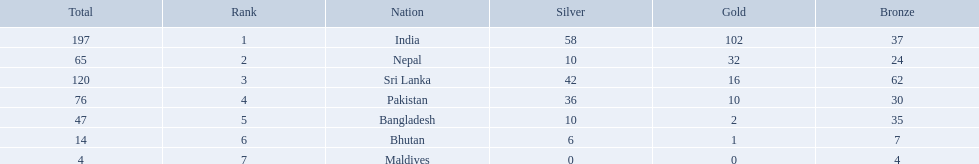Which countries won medals? India, Nepal, Sri Lanka, Pakistan, Bangladesh, Bhutan, Maldives. Which won the most? India. Which won the fewest? Maldives. 